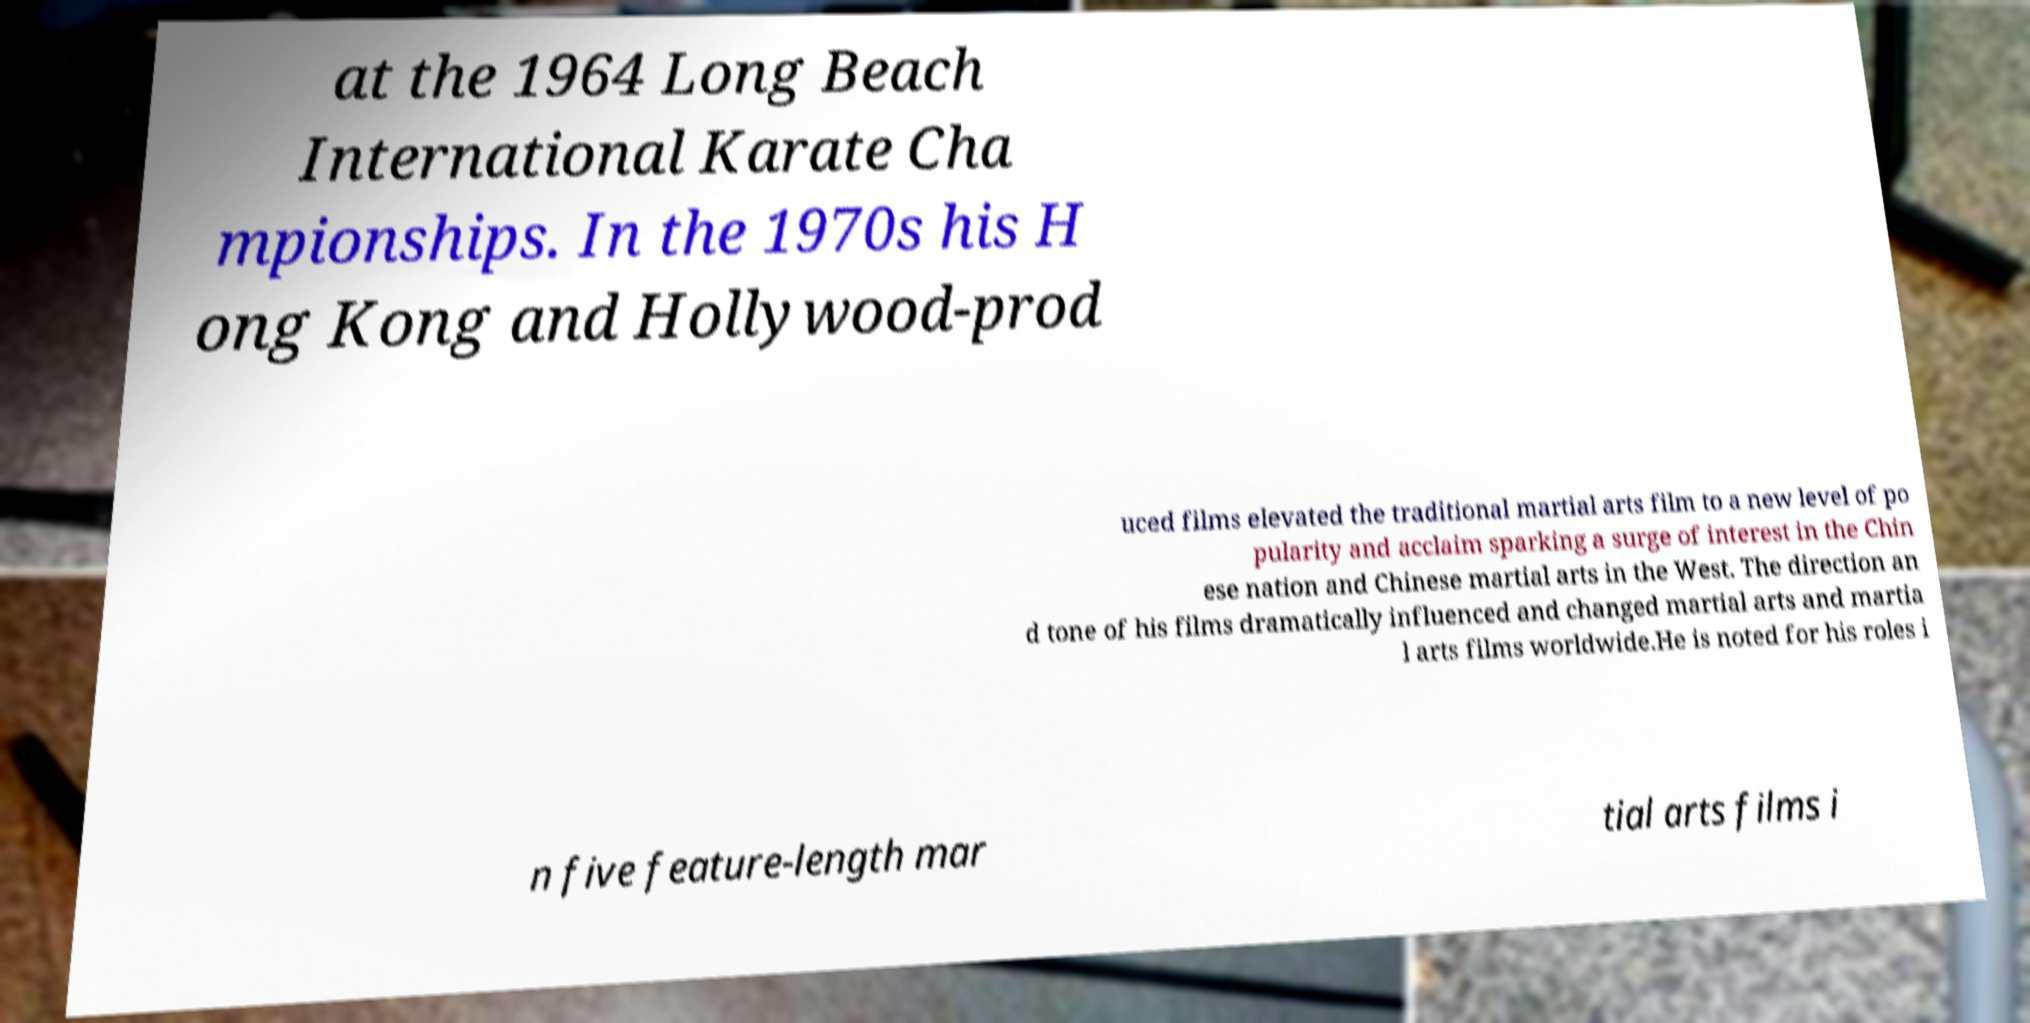What messages or text are displayed in this image? I need them in a readable, typed format. at the 1964 Long Beach International Karate Cha mpionships. In the 1970s his H ong Kong and Hollywood-prod uced films elevated the traditional martial arts film to a new level of po pularity and acclaim sparking a surge of interest in the Chin ese nation and Chinese martial arts in the West. The direction an d tone of his films dramatically influenced and changed martial arts and martia l arts films worldwide.He is noted for his roles i n five feature-length mar tial arts films i 